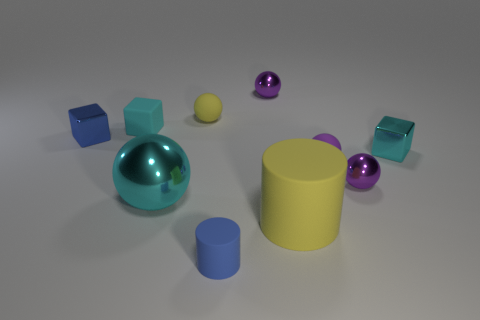Subtract all small cyan rubber blocks. How many blocks are left? 2 Subtract 5 spheres. How many spheres are left? 0 Subtract all yellow balls. How many balls are left? 4 Subtract all cubes. How many objects are left? 7 Subtract all yellow cylinders. Subtract all yellow blocks. How many cylinders are left? 1 Subtract all purple spheres. How many purple cylinders are left? 0 Subtract all big metallic objects. Subtract all yellow rubber spheres. How many objects are left? 8 Add 3 blue rubber cylinders. How many blue rubber cylinders are left? 4 Add 8 small blue matte objects. How many small blue matte objects exist? 9 Subtract 0 green spheres. How many objects are left? 10 